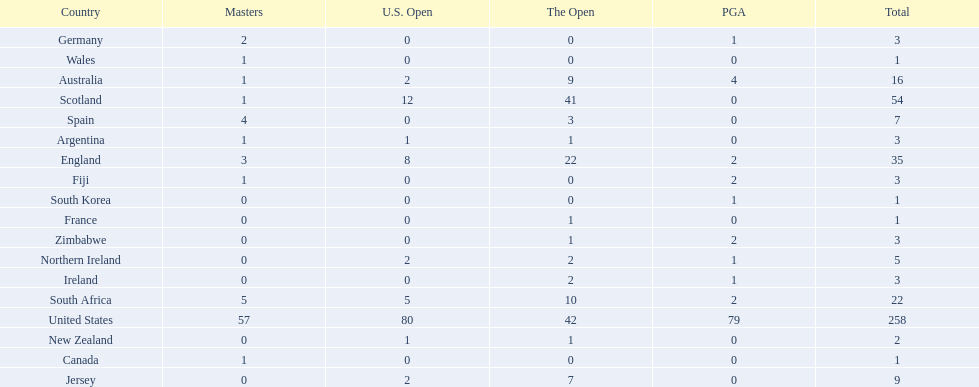What are all the countries? United States, Scotland, England, South Africa, Australia, Jersey, Spain, Northern Ireland, Argentina, Fiji, Germany, Ireland, Zimbabwe, New Zealand, Canada, France, South Korea, Wales. Which ones are located in africa? South Africa, Zimbabwe. Of those, which has the least champion golfers? Zimbabwe. 